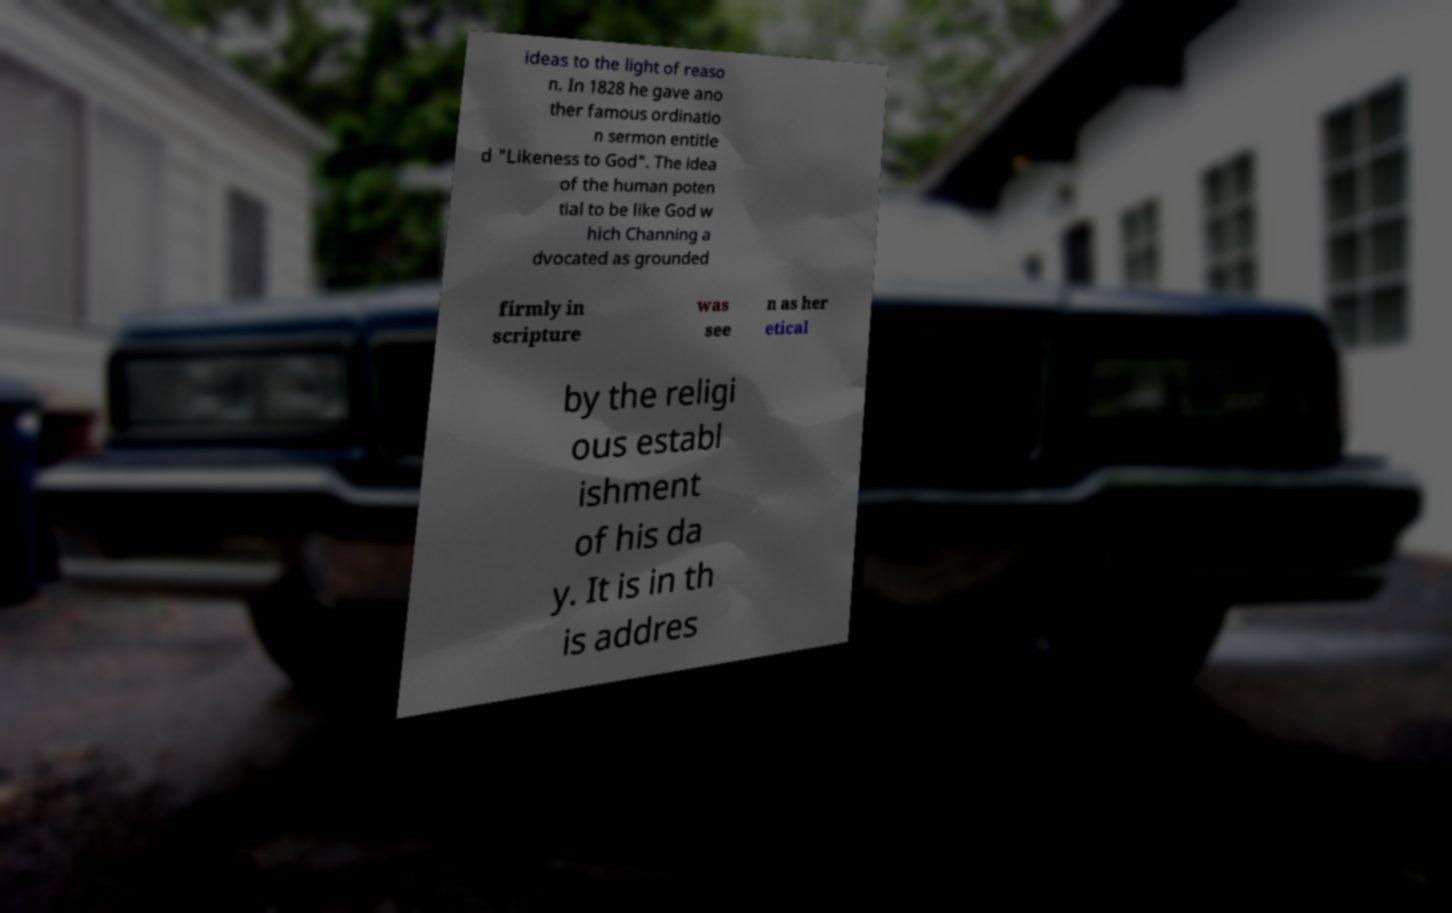Can you read and provide the text displayed in the image?This photo seems to have some interesting text. Can you extract and type it out for me? ideas to the light of reaso n. In 1828 he gave ano ther famous ordinatio n sermon entitle d "Likeness to God". The idea of the human poten tial to be like God w hich Channing a dvocated as grounded firmly in scripture was see n as her etical by the religi ous establ ishment of his da y. It is in th is addres 